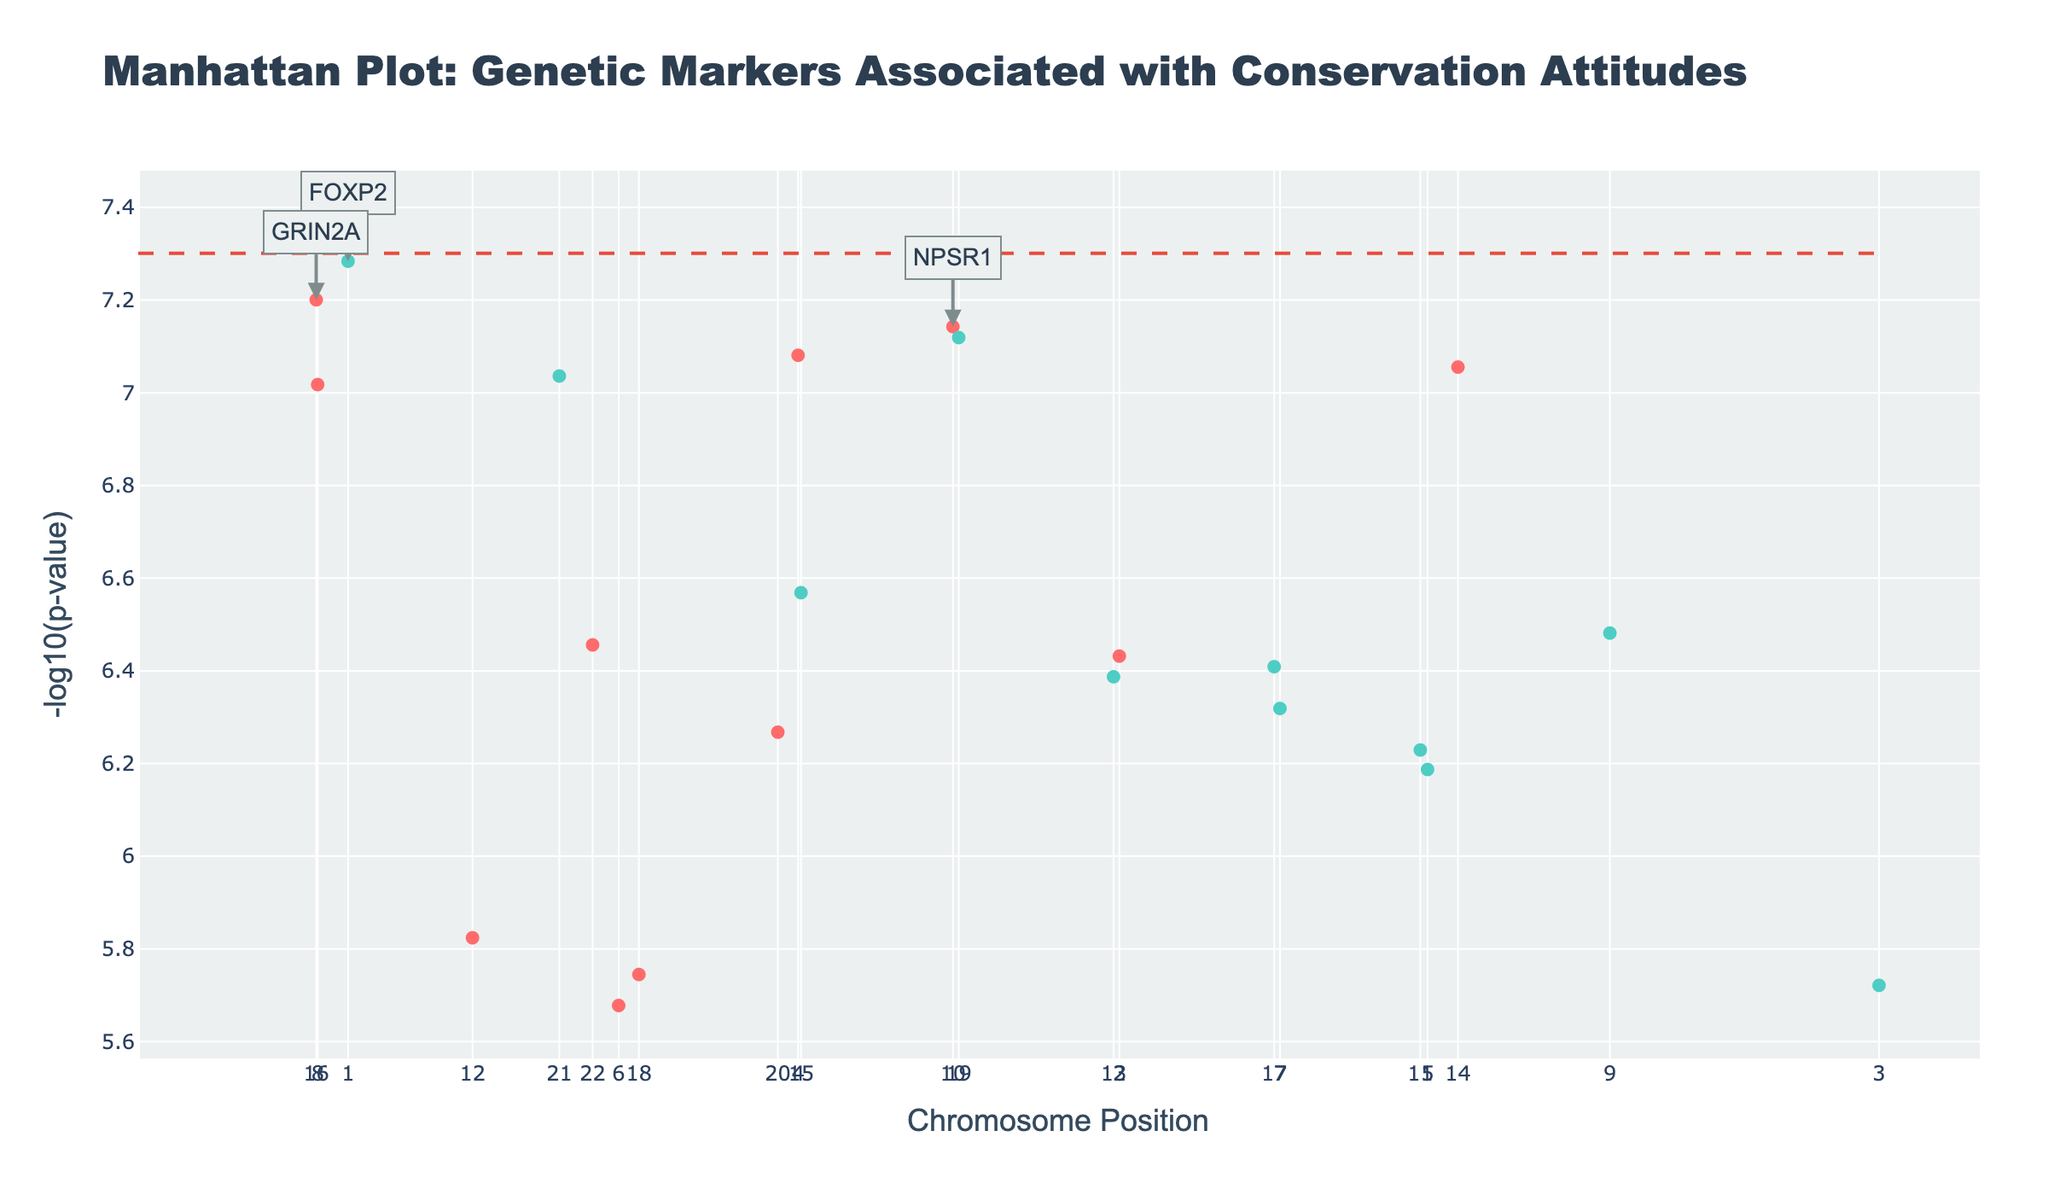What does the threshold line in the plot represent? The threshold line represents the significance level (typically p < 5e-8) indicating the minimum -log10(p-value) a genetic marker must have to be considered statistically significant.
Answer: Significance threshold How many genetic markers have a -log10(p-value) greater than 7? To answer this, you would count the number of points above the y-axis value of 7. There are four points: one on chromosome 1, one on chromosome 8, one on chromosome 14, and one on chromosome 16.
Answer: 4 Which chromosome has the genetic marker with the highest -log10(p-value)? By looking at the highest point on the y-axis, we see it is on chromosome 1.
Answer: Chromosome 1 What gene is associated with an extreme emotional response to habitat loss, and on which chromosome is it located? Look for the trait "Emotional response to habitat loss" in the hover text of points, which is associated with the gene "COMT" on chromosome 4.
Answer: COMT on chromosome 4 Between chromosomes 1 and 10, which one has more significant hits (points over the threshold line)? Count the points above the threshold line for chromosomes 1 and 10. Chromosome 1 has one point above the line, and chromosome 10 also has one point above the line.
Answer: Equal (both have 1) Which genetic marker is located at position around 12,300,000, and what trait is it associated with? Searching the plot, at around 12,300,000 position, locate the hover text, it is associated with the gene ESR1 and the trait "Nurturing attitude towards ecosystems."
Answer: ESR1, Nurturing attitude towards ecosystems What is the -log10(p-value) of the genetic marker associated with anxiety about climate change, and is it significantly above the threshold? Locate the marker associated with "Anxiety about climate change," which is on chromosome 10. Its -log10(p-value) is around 7.14, which is above the threshold (7).
Answer: Around 7.14, yes Among the annotations for top hits, which gene is located the furthest to the right on the plot? Look at the annotated gene names and their x-axis positions, the furthest one to the right among top hits is "CRHR1".
Answer: CRHR1 What is the trend in the number of significant hits across chromosomes, and which chromosome has the least number of hits? Count the points above the threshold line for each chromosome and compare. Chromosome 18 has only one hit, the least compared to others.
Answer: Chromosome 18 What color is used to represent markers on even chromosomes, and what is its purpose? The markers on even chromosomes have a different color (a darker teal), which helps to visually distinguish between neighboring chromosomes.
Answer: Dark teal, distinguish chromosomes 